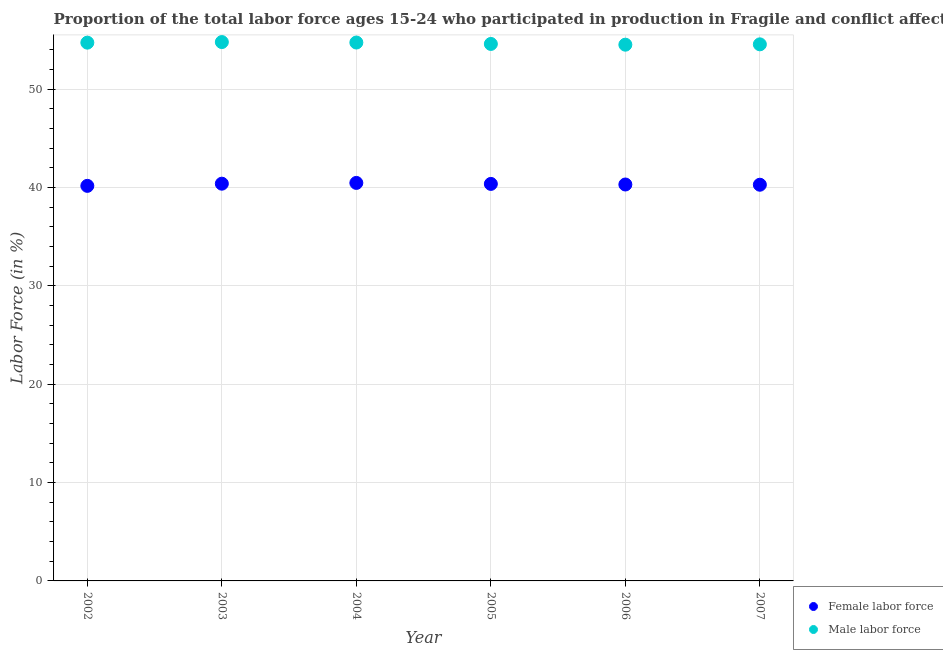How many different coloured dotlines are there?
Offer a very short reply. 2. What is the percentage of male labour force in 2002?
Give a very brief answer. 54.74. Across all years, what is the maximum percentage of female labor force?
Your response must be concise. 40.48. Across all years, what is the minimum percentage of female labor force?
Offer a terse response. 40.18. In which year was the percentage of male labour force minimum?
Offer a very short reply. 2006. What is the total percentage of female labor force in the graph?
Provide a succinct answer. 242.05. What is the difference between the percentage of male labour force in 2002 and that in 2003?
Offer a very short reply. -0.06. What is the difference between the percentage of male labour force in 2003 and the percentage of female labor force in 2002?
Ensure brevity in your answer.  14.62. What is the average percentage of female labor force per year?
Offer a terse response. 40.34. In the year 2003, what is the difference between the percentage of female labor force and percentage of male labour force?
Make the answer very short. -14.4. In how many years, is the percentage of female labor force greater than 46 %?
Your response must be concise. 0. What is the ratio of the percentage of male labour force in 2003 to that in 2004?
Offer a very short reply. 1. Is the percentage of female labor force in 2003 less than that in 2004?
Give a very brief answer. Yes. Is the difference between the percentage of male labour force in 2002 and 2004 greater than the difference between the percentage of female labor force in 2002 and 2004?
Your answer should be very brief. Yes. What is the difference between the highest and the second highest percentage of male labour force?
Ensure brevity in your answer.  0.05. What is the difference between the highest and the lowest percentage of female labor force?
Keep it short and to the point. 0.3. Is the sum of the percentage of male labour force in 2004 and 2005 greater than the maximum percentage of female labor force across all years?
Your answer should be compact. Yes. How many dotlines are there?
Ensure brevity in your answer.  2. How many years are there in the graph?
Offer a very short reply. 6. Are the values on the major ticks of Y-axis written in scientific E-notation?
Offer a terse response. No. Does the graph contain any zero values?
Your response must be concise. No. Does the graph contain grids?
Ensure brevity in your answer.  Yes. What is the title of the graph?
Your response must be concise. Proportion of the total labor force ages 15-24 who participated in production in Fragile and conflict affected situations. What is the label or title of the Y-axis?
Keep it short and to the point. Labor Force (in %). What is the Labor Force (in %) of Female labor force in 2002?
Ensure brevity in your answer.  40.18. What is the Labor Force (in %) in Male labor force in 2002?
Make the answer very short. 54.74. What is the Labor Force (in %) in Female labor force in 2003?
Offer a terse response. 40.4. What is the Labor Force (in %) of Male labor force in 2003?
Keep it short and to the point. 54.8. What is the Labor Force (in %) in Female labor force in 2004?
Give a very brief answer. 40.48. What is the Labor Force (in %) of Male labor force in 2004?
Keep it short and to the point. 54.76. What is the Labor Force (in %) of Female labor force in 2005?
Offer a terse response. 40.38. What is the Labor Force (in %) in Male labor force in 2005?
Make the answer very short. 54.61. What is the Labor Force (in %) of Female labor force in 2006?
Provide a succinct answer. 40.32. What is the Labor Force (in %) of Male labor force in 2006?
Your response must be concise. 54.54. What is the Labor Force (in %) of Female labor force in 2007?
Your answer should be very brief. 40.29. What is the Labor Force (in %) of Male labor force in 2007?
Offer a very short reply. 54.57. Across all years, what is the maximum Labor Force (in %) in Female labor force?
Your answer should be very brief. 40.48. Across all years, what is the maximum Labor Force (in %) of Male labor force?
Ensure brevity in your answer.  54.8. Across all years, what is the minimum Labor Force (in %) of Female labor force?
Keep it short and to the point. 40.18. Across all years, what is the minimum Labor Force (in %) of Male labor force?
Keep it short and to the point. 54.54. What is the total Labor Force (in %) in Female labor force in the graph?
Give a very brief answer. 242.05. What is the total Labor Force (in %) in Male labor force in the graph?
Provide a succinct answer. 328.03. What is the difference between the Labor Force (in %) in Female labor force in 2002 and that in 2003?
Your answer should be compact. -0.22. What is the difference between the Labor Force (in %) of Male labor force in 2002 and that in 2003?
Keep it short and to the point. -0.06. What is the difference between the Labor Force (in %) of Female labor force in 2002 and that in 2004?
Your response must be concise. -0.3. What is the difference between the Labor Force (in %) in Male labor force in 2002 and that in 2004?
Your answer should be compact. -0.01. What is the difference between the Labor Force (in %) in Female labor force in 2002 and that in 2005?
Your answer should be very brief. -0.2. What is the difference between the Labor Force (in %) of Male labor force in 2002 and that in 2005?
Provide a short and direct response. 0.13. What is the difference between the Labor Force (in %) of Female labor force in 2002 and that in 2006?
Make the answer very short. -0.14. What is the difference between the Labor Force (in %) of Male labor force in 2002 and that in 2006?
Your response must be concise. 0.21. What is the difference between the Labor Force (in %) of Female labor force in 2002 and that in 2007?
Offer a very short reply. -0.11. What is the difference between the Labor Force (in %) of Male labor force in 2002 and that in 2007?
Keep it short and to the point. 0.17. What is the difference between the Labor Force (in %) of Female labor force in 2003 and that in 2004?
Offer a very short reply. -0.08. What is the difference between the Labor Force (in %) of Male labor force in 2003 and that in 2004?
Offer a very short reply. 0.05. What is the difference between the Labor Force (in %) of Female labor force in 2003 and that in 2005?
Make the answer very short. 0.02. What is the difference between the Labor Force (in %) in Male labor force in 2003 and that in 2005?
Keep it short and to the point. 0.19. What is the difference between the Labor Force (in %) in Female labor force in 2003 and that in 2006?
Your answer should be very brief. 0.08. What is the difference between the Labor Force (in %) of Male labor force in 2003 and that in 2006?
Keep it short and to the point. 0.27. What is the difference between the Labor Force (in %) in Female labor force in 2003 and that in 2007?
Offer a terse response. 0.11. What is the difference between the Labor Force (in %) in Male labor force in 2003 and that in 2007?
Provide a short and direct response. 0.23. What is the difference between the Labor Force (in %) in Female labor force in 2004 and that in 2005?
Make the answer very short. 0.1. What is the difference between the Labor Force (in %) of Male labor force in 2004 and that in 2005?
Ensure brevity in your answer.  0.14. What is the difference between the Labor Force (in %) in Female labor force in 2004 and that in 2006?
Your answer should be compact. 0.16. What is the difference between the Labor Force (in %) of Male labor force in 2004 and that in 2006?
Your answer should be compact. 0.22. What is the difference between the Labor Force (in %) in Female labor force in 2004 and that in 2007?
Ensure brevity in your answer.  0.18. What is the difference between the Labor Force (in %) of Male labor force in 2004 and that in 2007?
Give a very brief answer. 0.18. What is the difference between the Labor Force (in %) in Female labor force in 2005 and that in 2006?
Provide a short and direct response. 0.06. What is the difference between the Labor Force (in %) in Male labor force in 2005 and that in 2006?
Make the answer very short. 0.08. What is the difference between the Labor Force (in %) in Female labor force in 2005 and that in 2007?
Give a very brief answer. 0.08. What is the difference between the Labor Force (in %) of Male labor force in 2005 and that in 2007?
Your answer should be compact. 0.04. What is the difference between the Labor Force (in %) in Female labor force in 2006 and that in 2007?
Your answer should be very brief. 0.02. What is the difference between the Labor Force (in %) of Male labor force in 2006 and that in 2007?
Keep it short and to the point. -0.04. What is the difference between the Labor Force (in %) of Female labor force in 2002 and the Labor Force (in %) of Male labor force in 2003?
Provide a short and direct response. -14.62. What is the difference between the Labor Force (in %) in Female labor force in 2002 and the Labor Force (in %) in Male labor force in 2004?
Give a very brief answer. -14.58. What is the difference between the Labor Force (in %) of Female labor force in 2002 and the Labor Force (in %) of Male labor force in 2005?
Keep it short and to the point. -14.43. What is the difference between the Labor Force (in %) of Female labor force in 2002 and the Labor Force (in %) of Male labor force in 2006?
Your answer should be very brief. -14.36. What is the difference between the Labor Force (in %) of Female labor force in 2002 and the Labor Force (in %) of Male labor force in 2007?
Offer a terse response. -14.39. What is the difference between the Labor Force (in %) of Female labor force in 2003 and the Labor Force (in %) of Male labor force in 2004?
Make the answer very short. -14.36. What is the difference between the Labor Force (in %) in Female labor force in 2003 and the Labor Force (in %) in Male labor force in 2005?
Your response must be concise. -14.21. What is the difference between the Labor Force (in %) of Female labor force in 2003 and the Labor Force (in %) of Male labor force in 2006?
Give a very brief answer. -14.14. What is the difference between the Labor Force (in %) of Female labor force in 2003 and the Labor Force (in %) of Male labor force in 2007?
Provide a succinct answer. -14.17. What is the difference between the Labor Force (in %) in Female labor force in 2004 and the Labor Force (in %) in Male labor force in 2005?
Your answer should be very brief. -14.13. What is the difference between the Labor Force (in %) of Female labor force in 2004 and the Labor Force (in %) of Male labor force in 2006?
Give a very brief answer. -14.06. What is the difference between the Labor Force (in %) in Female labor force in 2004 and the Labor Force (in %) in Male labor force in 2007?
Make the answer very short. -14.09. What is the difference between the Labor Force (in %) of Female labor force in 2005 and the Labor Force (in %) of Male labor force in 2006?
Give a very brief answer. -14.16. What is the difference between the Labor Force (in %) of Female labor force in 2005 and the Labor Force (in %) of Male labor force in 2007?
Your answer should be very brief. -14.2. What is the difference between the Labor Force (in %) in Female labor force in 2006 and the Labor Force (in %) in Male labor force in 2007?
Your response must be concise. -14.26. What is the average Labor Force (in %) of Female labor force per year?
Make the answer very short. 40.34. What is the average Labor Force (in %) of Male labor force per year?
Your answer should be compact. 54.67. In the year 2002, what is the difference between the Labor Force (in %) of Female labor force and Labor Force (in %) of Male labor force?
Make the answer very short. -14.56. In the year 2003, what is the difference between the Labor Force (in %) of Female labor force and Labor Force (in %) of Male labor force?
Provide a short and direct response. -14.4. In the year 2004, what is the difference between the Labor Force (in %) in Female labor force and Labor Force (in %) in Male labor force?
Your answer should be very brief. -14.28. In the year 2005, what is the difference between the Labor Force (in %) in Female labor force and Labor Force (in %) in Male labor force?
Keep it short and to the point. -14.24. In the year 2006, what is the difference between the Labor Force (in %) in Female labor force and Labor Force (in %) in Male labor force?
Provide a short and direct response. -14.22. In the year 2007, what is the difference between the Labor Force (in %) in Female labor force and Labor Force (in %) in Male labor force?
Provide a short and direct response. -14.28. What is the ratio of the Labor Force (in %) in Female labor force in 2002 to that in 2003?
Your answer should be compact. 0.99. What is the ratio of the Labor Force (in %) of Male labor force in 2002 to that in 2003?
Offer a terse response. 1. What is the ratio of the Labor Force (in %) in Female labor force in 2002 to that in 2004?
Offer a terse response. 0.99. What is the ratio of the Labor Force (in %) in Male labor force in 2002 to that in 2004?
Give a very brief answer. 1. What is the ratio of the Labor Force (in %) in Female labor force in 2002 to that in 2005?
Provide a succinct answer. 1. What is the ratio of the Labor Force (in %) in Male labor force in 2002 to that in 2005?
Your answer should be very brief. 1. What is the ratio of the Labor Force (in %) of Female labor force in 2002 to that in 2006?
Offer a very short reply. 1. What is the ratio of the Labor Force (in %) in Male labor force in 2002 to that in 2006?
Offer a terse response. 1. What is the ratio of the Labor Force (in %) of Female labor force in 2002 to that in 2007?
Provide a succinct answer. 1. What is the ratio of the Labor Force (in %) of Male labor force in 2002 to that in 2007?
Ensure brevity in your answer.  1. What is the ratio of the Labor Force (in %) of Female labor force in 2003 to that in 2006?
Your response must be concise. 1. What is the ratio of the Labor Force (in %) of Male labor force in 2003 to that in 2006?
Offer a terse response. 1. What is the ratio of the Labor Force (in %) of Male labor force in 2003 to that in 2007?
Keep it short and to the point. 1. What is the ratio of the Labor Force (in %) in Female labor force in 2004 to that in 2006?
Your response must be concise. 1. What is the ratio of the Labor Force (in %) of Male labor force in 2005 to that in 2006?
Ensure brevity in your answer.  1. What is the ratio of the Labor Force (in %) of Female labor force in 2005 to that in 2007?
Provide a short and direct response. 1. What is the ratio of the Labor Force (in %) in Male labor force in 2005 to that in 2007?
Provide a succinct answer. 1. What is the difference between the highest and the second highest Labor Force (in %) in Female labor force?
Provide a short and direct response. 0.08. What is the difference between the highest and the second highest Labor Force (in %) of Male labor force?
Make the answer very short. 0.05. What is the difference between the highest and the lowest Labor Force (in %) in Female labor force?
Your answer should be compact. 0.3. What is the difference between the highest and the lowest Labor Force (in %) in Male labor force?
Your answer should be very brief. 0.27. 